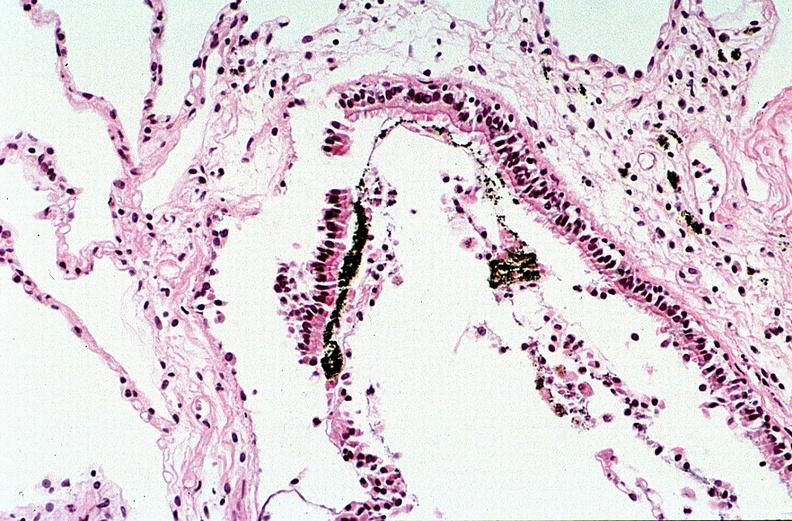s intramural one lesion present?
Answer the question using a single word or phrase. No 